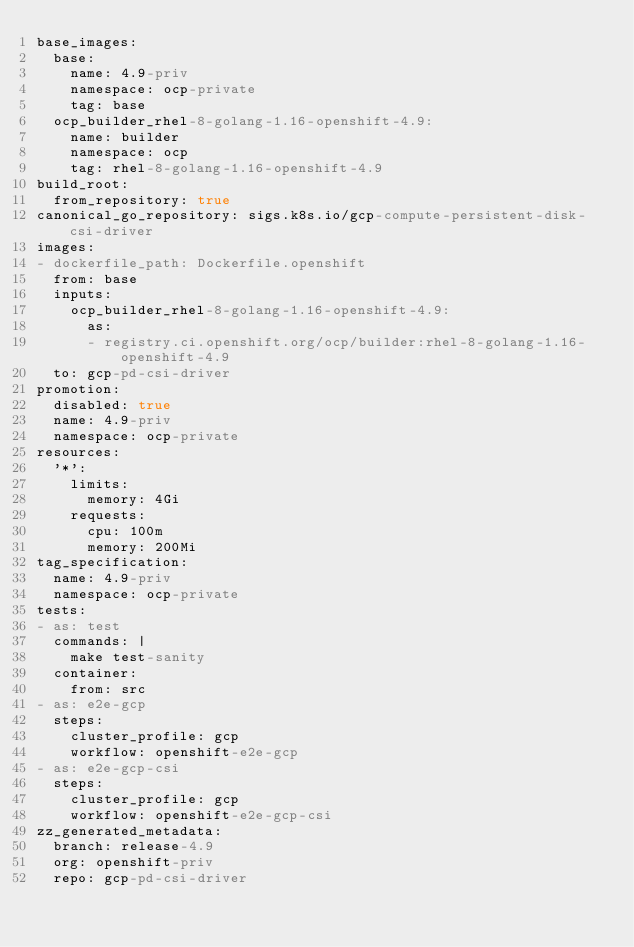<code> <loc_0><loc_0><loc_500><loc_500><_YAML_>base_images:
  base:
    name: 4.9-priv
    namespace: ocp-private
    tag: base
  ocp_builder_rhel-8-golang-1.16-openshift-4.9:
    name: builder
    namespace: ocp
    tag: rhel-8-golang-1.16-openshift-4.9
build_root:
  from_repository: true
canonical_go_repository: sigs.k8s.io/gcp-compute-persistent-disk-csi-driver
images:
- dockerfile_path: Dockerfile.openshift
  from: base
  inputs:
    ocp_builder_rhel-8-golang-1.16-openshift-4.9:
      as:
      - registry.ci.openshift.org/ocp/builder:rhel-8-golang-1.16-openshift-4.9
  to: gcp-pd-csi-driver
promotion:
  disabled: true
  name: 4.9-priv
  namespace: ocp-private
resources:
  '*':
    limits:
      memory: 4Gi
    requests:
      cpu: 100m
      memory: 200Mi
tag_specification:
  name: 4.9-priv
  namespace: ocp-private
tests:
- as: test
  commands: |
    make test-sanity
  container:
    from: src
- as: e2e-gcp
  steps:
    cluster_profile: gcp
    workflow: openshift-e2e-gcp
- as: e2e-gcp-csi
  steps:
    cluster_profile: gcp
    workflow: openshift-e2e-gcp-csi
zz_generated_metadata:
  branch: release-4.9
  org: openshift-priv
  repo: gcp-pd-csi-driver
</code> 